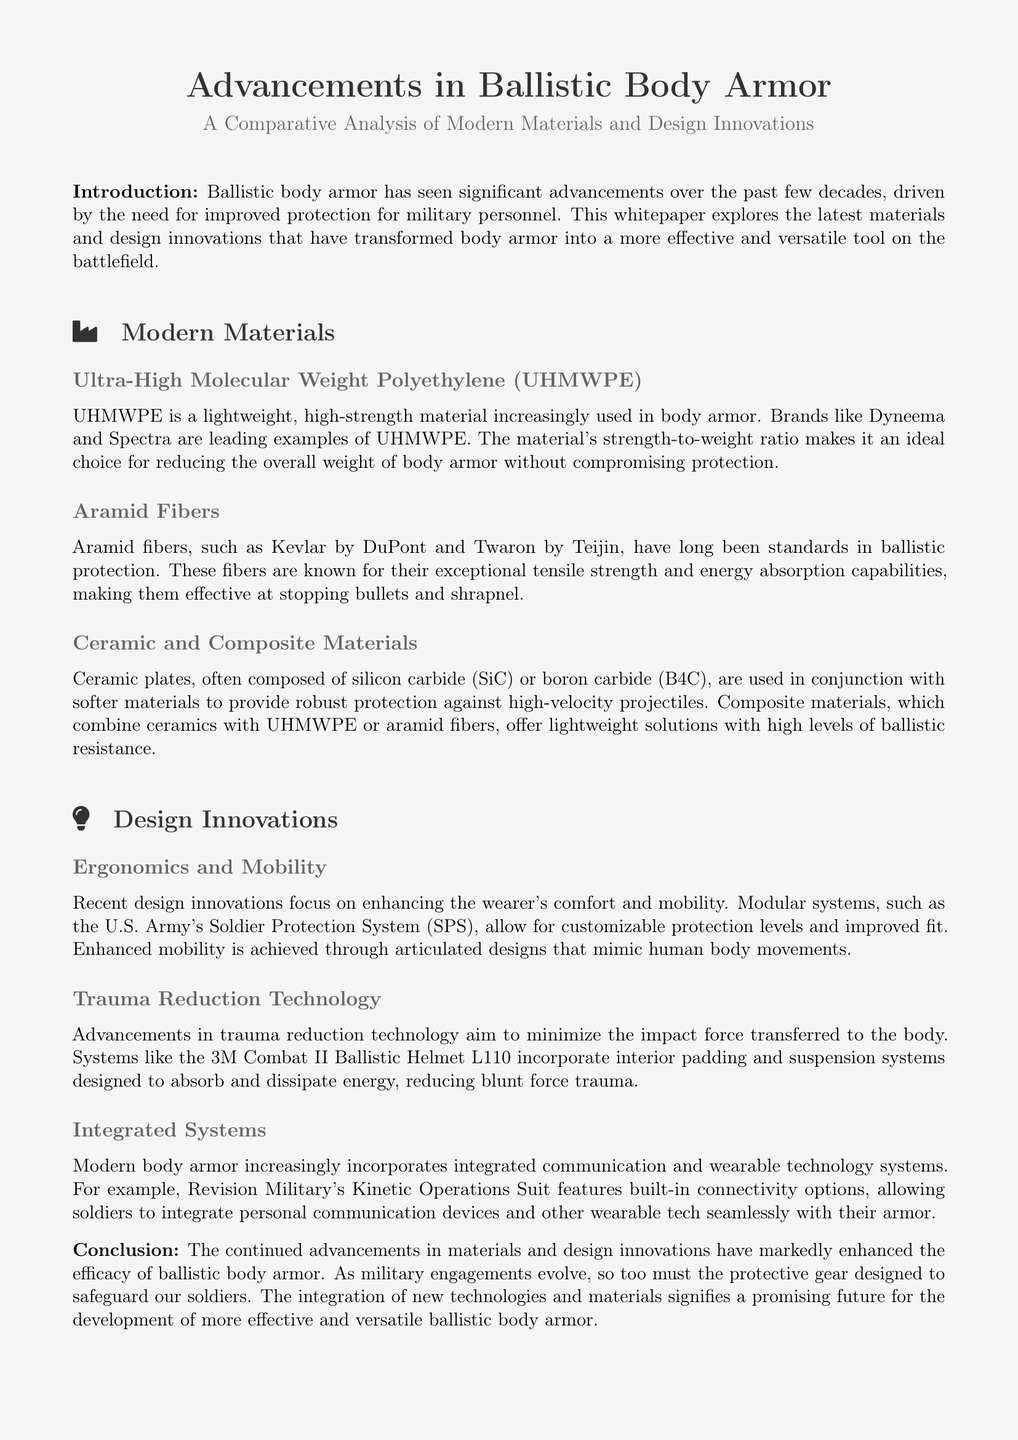What is the main topic of the whitepaper? The whitepaper explores advancements in materials and design innovations in ballistic body armor.
Answer: Advancements in Ballistic Body Armor What are the two leading brands of UHMWPE mentioned? The document lists Dyneema and Spectra as leading brands of UHMWPE.
Answer: Dyneema and Spectra Which material is known for its exceptional tensile strength? The document states that aramid fibers, such as Kevlar and Twaron, are known for their exceptional tensile strength.
Answer: Aramid fibers What is the purpose of the U.S. Army's Soldier Protection System? The Soldier Protection System is designed for customizable protection levels and improved fit.
Answer: Customizable protection What technology does the 3M Combat II Ballistic Helmet L110 incorporate? The helmet incorporates trauma reduction technology designed to absorb and dissipate energy.
Answer: Trauma reduction technology Which ceramics are mentioned in the context of ballistic plates? Silicon carbide and boron carbide are mentioned as materials used in ceramic plates.
Answer: Silicon carbide and boron carbide What trend is observed in the design of modern body armor? The document mentions that modern armor designs focus on enhancing comfort and mobility for the wearer.
Answer: Comfort and mobility What kind of technology is integrated within modern body armor? Integrated communication and wearable technology systems are increasingly incorporated into body armor.
Answer: Integrated communication technology What is the key benefit of composite materials in body armor? Composite materials offer lightweight solutions with high levels of ballistic resistance.
Answer: Lightweight solutions with high resistance 